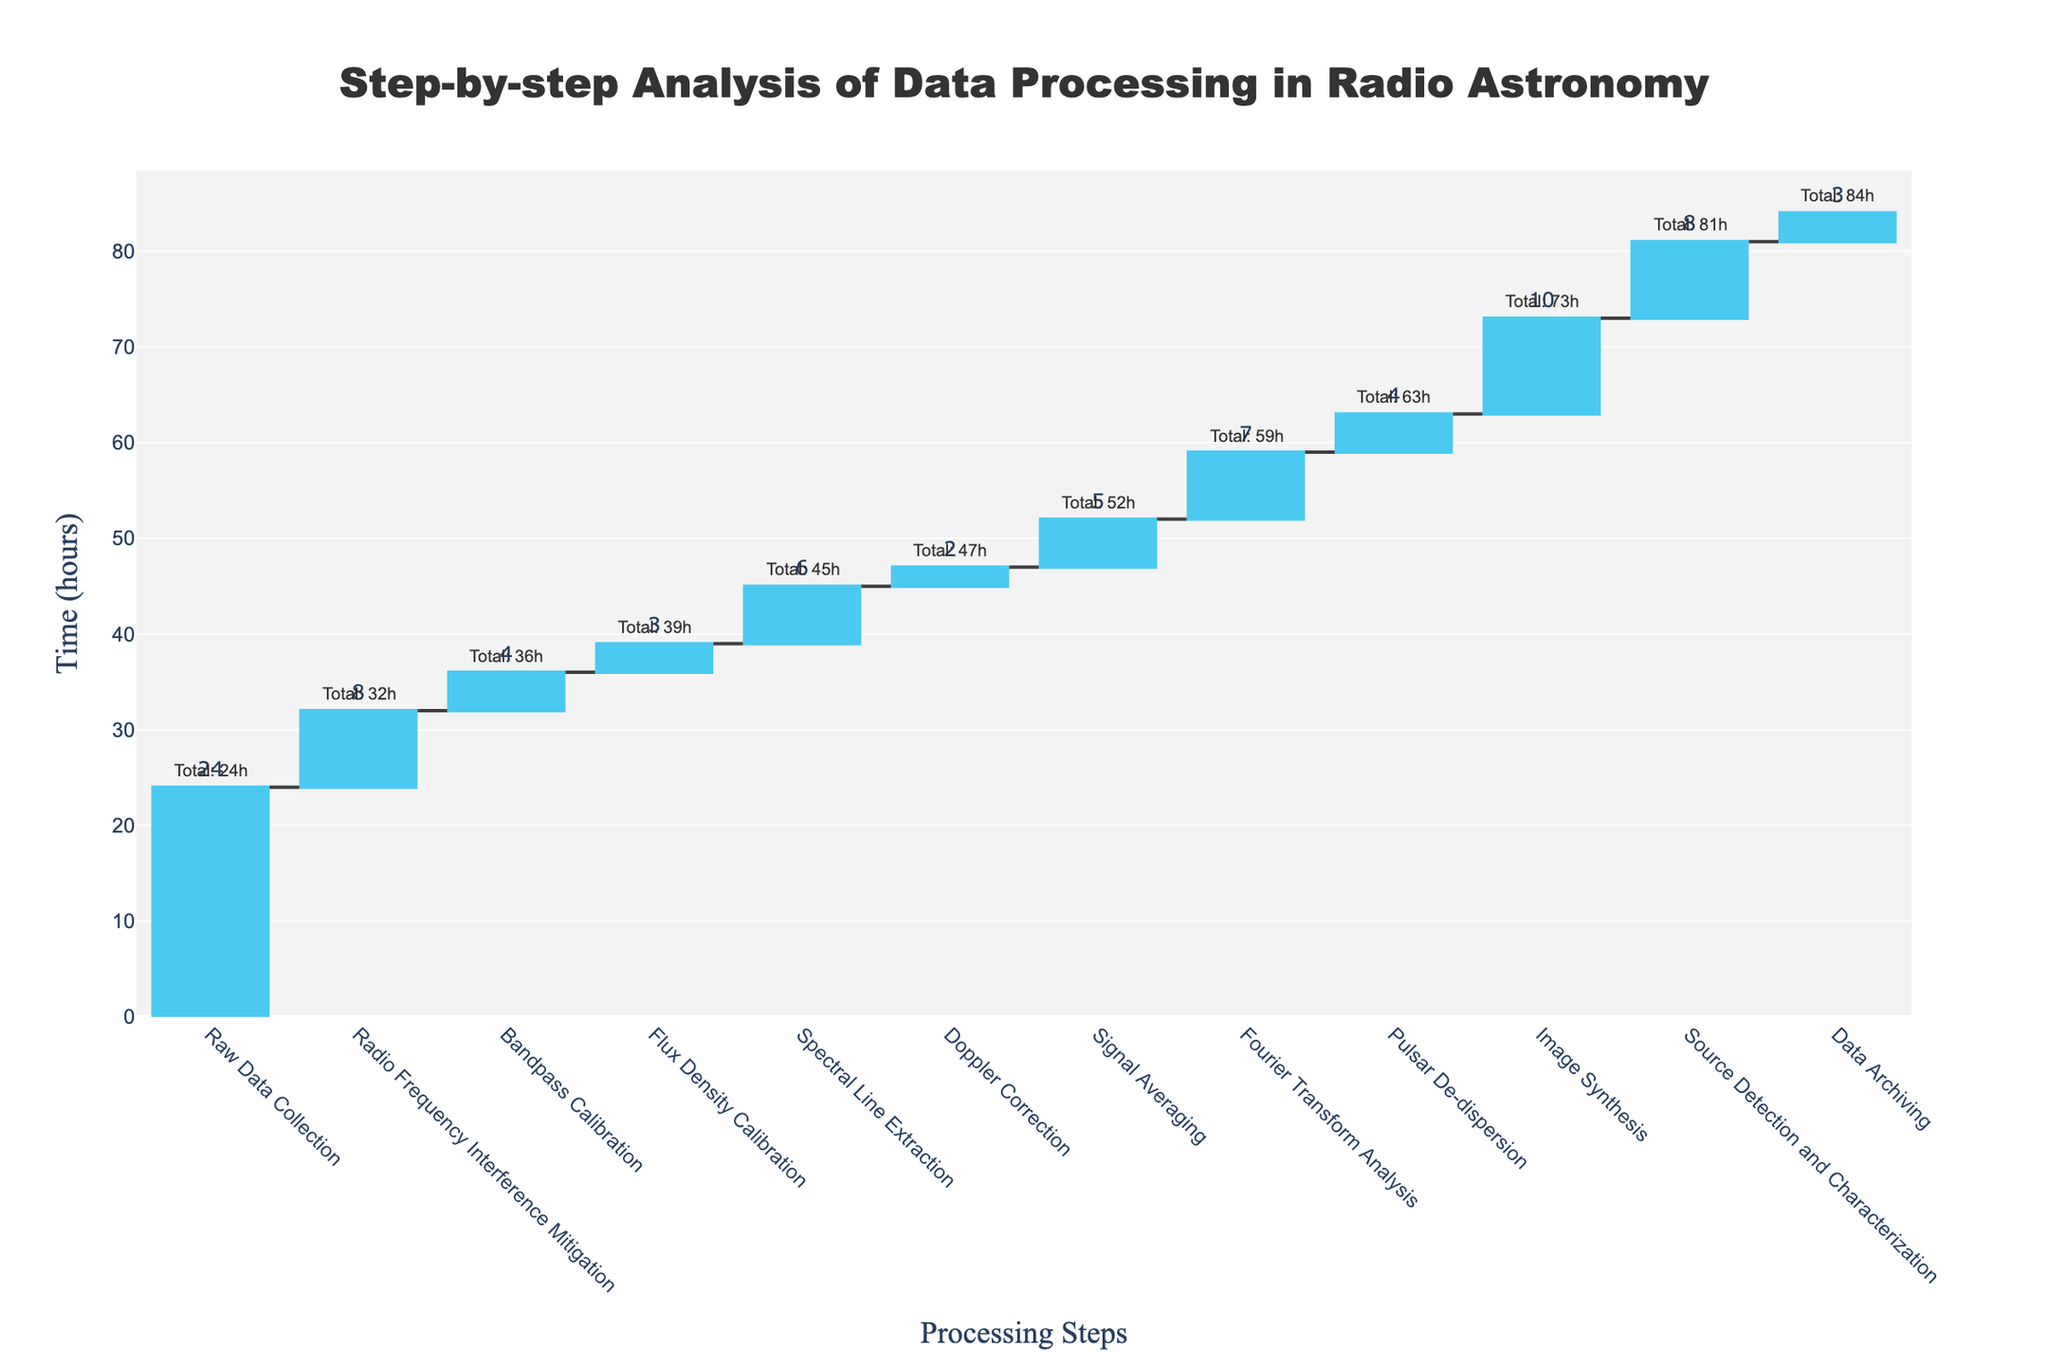What is the total time spent on data processing in radio astronomy? To find the total time, look at the final cumulative time which represents the sum of all individual processing times. The final cumulative time is shown in the last annotation above the last bar.
Answer: 84 hours Which processing step takes the longest time to complete? To determine the step with the longest duration, look at the heights of the individual bars and refer to the text annotations for each bar. The step with the highest value is the longest.
Answer: Raw Data Collection How much more time is spent on Image Synthesis compared to Doppler Correction? Find the time for Image Synthesis (10 hours) and Doppler Correction (2 hours) by referring to the text annotations next to these bars. Then subtract the smaller value from the larger one: 10 - 2 = 8 hours.
Answer: 8 hours What is the cumulative time after the Bandpass Calibration step? Refer to the annotation above the Bandpass Calibration bar which shows the cumulative time after this step.
Answer: 36 hours What is the combined time for Radio Frequency Interference Mitigation and Flux Density Calibration? To find the combined time, add the individual times for Radio Frequency Interference Mitigation (8 hours) and Flux Density Calibration (3 hours) by referring to the text annotations: 8 + 3 = 11 hours.
Answer: 11 hours Between which two steps does the cumulative time increase the most? To find the largest increase in cumulative time between steps, compare the vertical differences (cumulative time annotations) between consecutive steps. The largest difference will indicate the biggest increase. The largest increase is between Raw Data Collection and Radio Frequency Interference Mitigation (24 to 32 hours, which is an increase of 8 hours).
Answer: Raw Data Collection and Radio Frequency Interference Mitigation How many steps take 4 hours to complete? Identify all steps with a time of 4 hours by looking at the text annotations on the bars. The steps with 4 hours are Bandpass Calibration and Pulsar De-dispersion.
Answer: 2 steps Which step immediately follows Spectral Line Extraction and what is its duration? Look at the order of steps and find the one that comes immediately after Spectral Line Extraction, then refer to the text annotation for its duration. The next step is Doppler Correction and its duration is 2 hours.
Answer: Doppler Correction, 2 hours What percentage of the total processing time is spent on Fourier Transform Analysis? First, find the time spent on Fourier Transform Analysis (7 hours) and the total time (84 hours). Then, compute the percentage: (7 / 84) * 100 = 8.33%.
Answer: Approximately 8.33% Between which two steps does the cumulative time increase the least? Compare the vertical differences in cumulative time between consecutive steps. The smallest difference indicates the least increase. The smallest increase is between Doppler Correction and Signal Averaging (47 to 52 hours, which is an increase of 5 hours).
Answer: Doppler Correction and Signal Averaging 